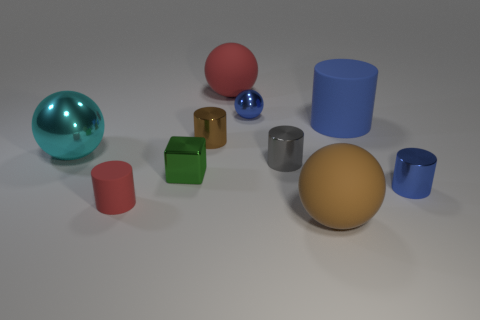Subtract 1 spheres. How many spheres are left? 3 Subtract all blue cylinders. How many cylinders are left? 3 Subtract all brown rubber balls. How many balls are left? 3 Subtract all purple spheres. Subtract all yellow cylinders. How many spheres are left? 4 Subtract all blocks. How many objects are left? 9 Subtract all large red objects. Subtract all big cyan things. How many objects are left? 8 Add 6 gray metal cylinders. How many gray metal cylinders are left? 7 Add 8 tiny brown things. How many tiny brown things exist? 9 Subtract 0 gray spheres. How many objects are left? 10 